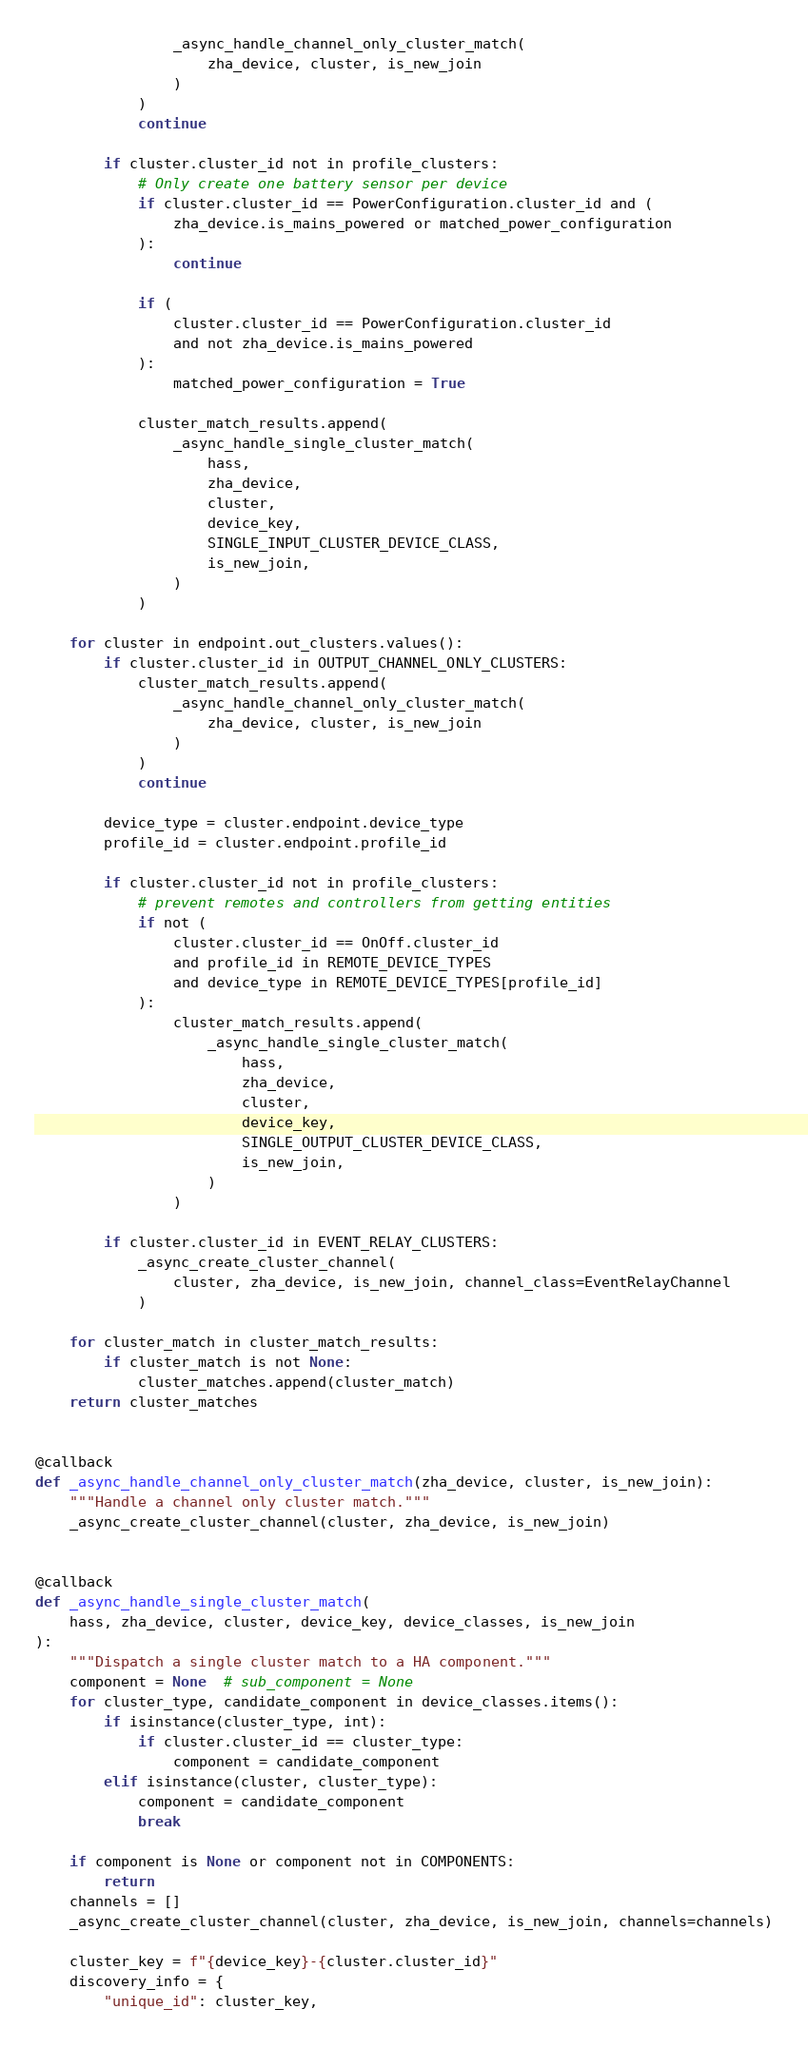<code> <loc_0><loc_0><loc_500><loc_500><_Python_>                _async_handle_channel_only_cluster_match(
                    zha_device, cluster, is_new_join
                )
            )
            continue

        if cluster.cluster_id not in profile_clusters:
            # Only create one battery sensor per device
            if cluster.cluster_id == PowerConfiguration.cluster_id and (
                zha_device.is_mains_powered or matched_power_configuration
            ):
                continue

            if (
                cluster.cluster_id == PowerConfiguration.cluster_id
                and not zha_device.is_mains_powered
            ):
                matched_power_configuration = True

            cluster_match_results.append(
                _async_handle_single_cluster_match(
                    hass,
                    zha_device,
                    cluster,
                    device_key,
                    SINGLE_INPUT_CLUSTER_DEVICE_CLASS,
                    is_new_join,
                )
            )

    for cluster in endpoint.out_clusters.values():
        if cluster.cluster_id in OUTPUT_CHANNEL_ONLY_CLUSTERS:
            cluster_match_results.append(
                _async_handle_channel_only_cluster_match(
                    zha_device, cluster, is_new_join
                )
            )
            continue

        device_type = cluster.endpoint.device_type
        profile_id = cluster.endpoint.profile_id

        if cluster.cluster_id not in profile_clusters:
            # prevent remotes and controllers from getting entities
            if not (
                cluster.cluster_id == OnOff.cluster_id
                and profile_id in REMOTE_DEVICE_TYPES
                and device_type in REMOTE_DEVICE_TYPES[profile_id]
            ):
                cluster_match_results.append(
                    _async_handle_single_cluster_match(
                        hass,
                        zha_device,
                        cluster,
                        device_key,
                        SINGLE_OUTPUT_CLUSTER_DEVICE_CLASS,
                        is_new_join,
                    )
                )

        if cluster.cluster_id in EVENT_RELAY_CLUSTERS:
            _async_create_cluster_channel(
                cluster, zha_device, is_new_join, channel_class=EventRelayChannel
            )

    for cluster_match in cluster_match_results:
        if cluster_match is not None:
            cluster_matches.append(cluster_match)
    return cluster_matches


@callback
def _async_handle_channel_only_cluster_match(zha_device, cluster, is_new_join):
    """Handle a channel only cluster match."""
    _async_create_cluster_channel(cluster, zha_device, is_new_join)


@callback
def _async_handle_single_cluster_match(
    hass, zha_device, cluster, device_key, device_classes, is_new_join
):
    """Dispatch a single cluster match to a HA component."""
    component = None  # sub_component = None
    for cluster_type, candidate_component in device_classes.items():
        if isinstance(cluster_type, int):
            if cluster.cluster_id == cluster_type:
                component = candidate_component
        elif isinstance(cluster, cluster_type):
            component = candidate_component
            break

    if component is None or component not in COMPONENTS:
        return
    channels = []
    _async_create_cluster_channel(cluster, zha_device, is_new_join, channels=channels)

    cluster_key = f"{device_key}-{cluster.cluster_id}"
    discovery_info = {
        "unique_id": cluster_key,</code> 